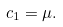Convert formula to latex. <formula><loc_0><loc_0><loc_500><loc_500>c _ { 1 } = \mu .</formula> 